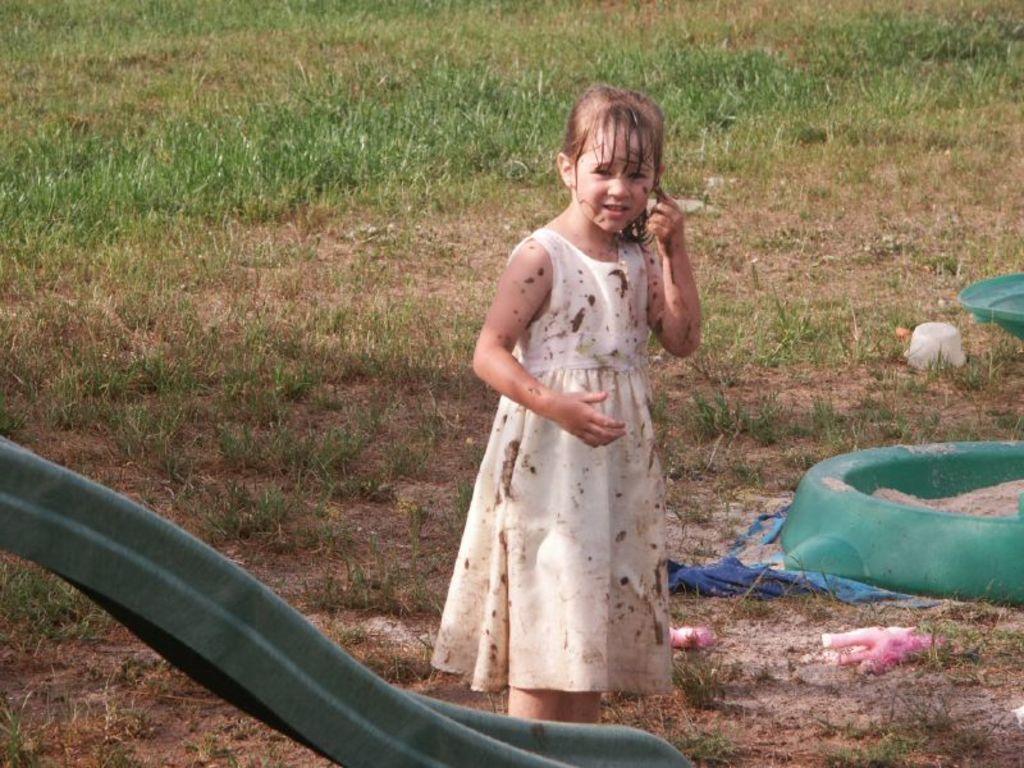How would you summarize this image in a sentence or two? In the background we can see the grass. In this picture we can see few objects on the ground. We can see a girl wearing a white frock. On the left side of the picture we can see an object. 